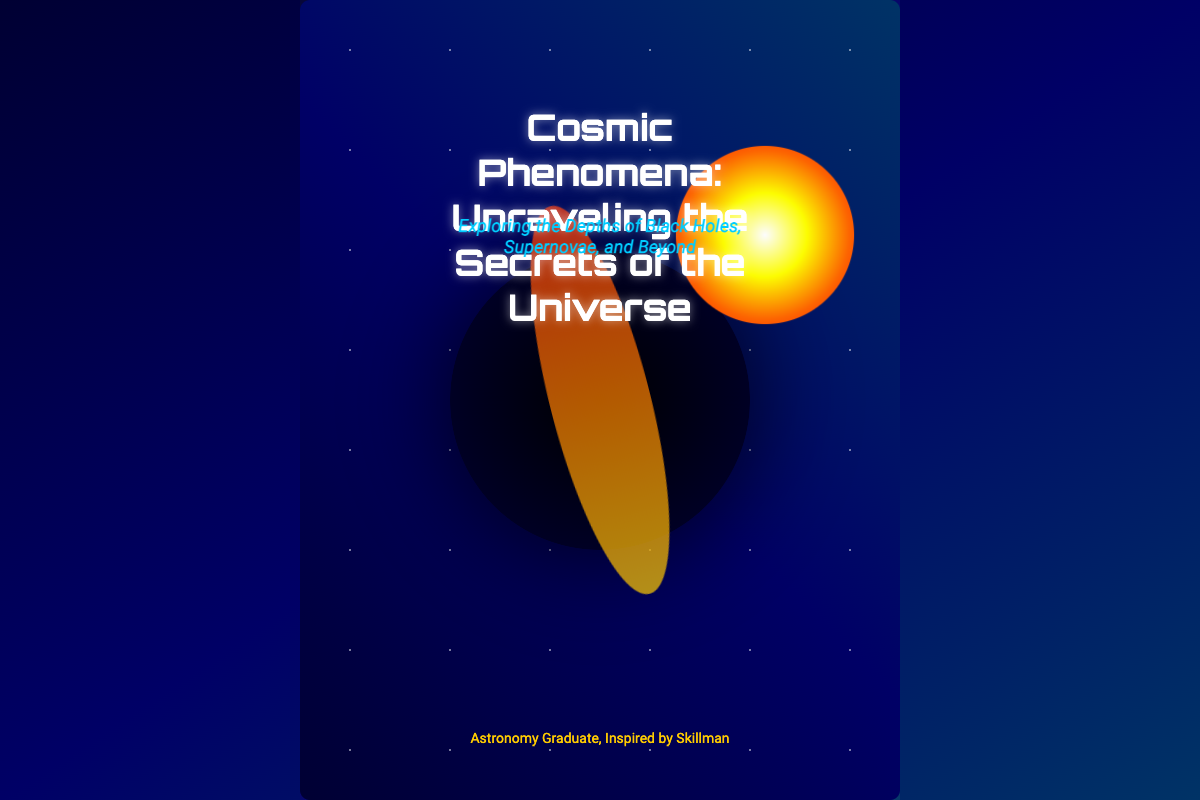What is the title of the book? The title is prominently displayed at the top of the cover.
Answer: Cosmic Phenomena: Unraveling the Secrets of the Universe Who is the author of the book? The author's name is mentioned at the bottom of the cover.
Answer: Astronomy Graduate, Inspired by Skillman What is illustrated in the center of the cover? The cover features a prominent visual element that represents a crucial cosmic phenomenon.
Answer: Black hole What is the subtitle of the book? The subtitle is located just below the title and describes the content of the book.
Answer: Exploring the Depths of Black Holes, Supernovae, and Beyond What is the color of the author's name? The author’s name is shown in a specific color that highlights it.
Answer: Yellow How many main cosmic events are referenced in the subtitle? The subtitle mentions multiple cosmic phenomena, indicating how many are discussed in the book.
Answer: Two What is the primary background color of the book cover? The book cover has a gradient background featuring dark colors.
Answer: Dark blue What type of visual effect is used for the supernova? The animation and color gradient create a specific visual impact for this cosmic event.
Answer: Pulsating What font is used for the title? The font style for the title is distinct and contributes to the overall theme of the book.
Answer: Orbitron 